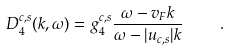<formula> <loc_0><loc_0><loc_500><loc_500>D _ { 4 } ^ { c , s } ( k , \omega ) = g _ { 4 } ^ { c , s } \frac { \omega - v _ { F } k } { \omega - | u _ { c , s } | k } \quad .</formula> 